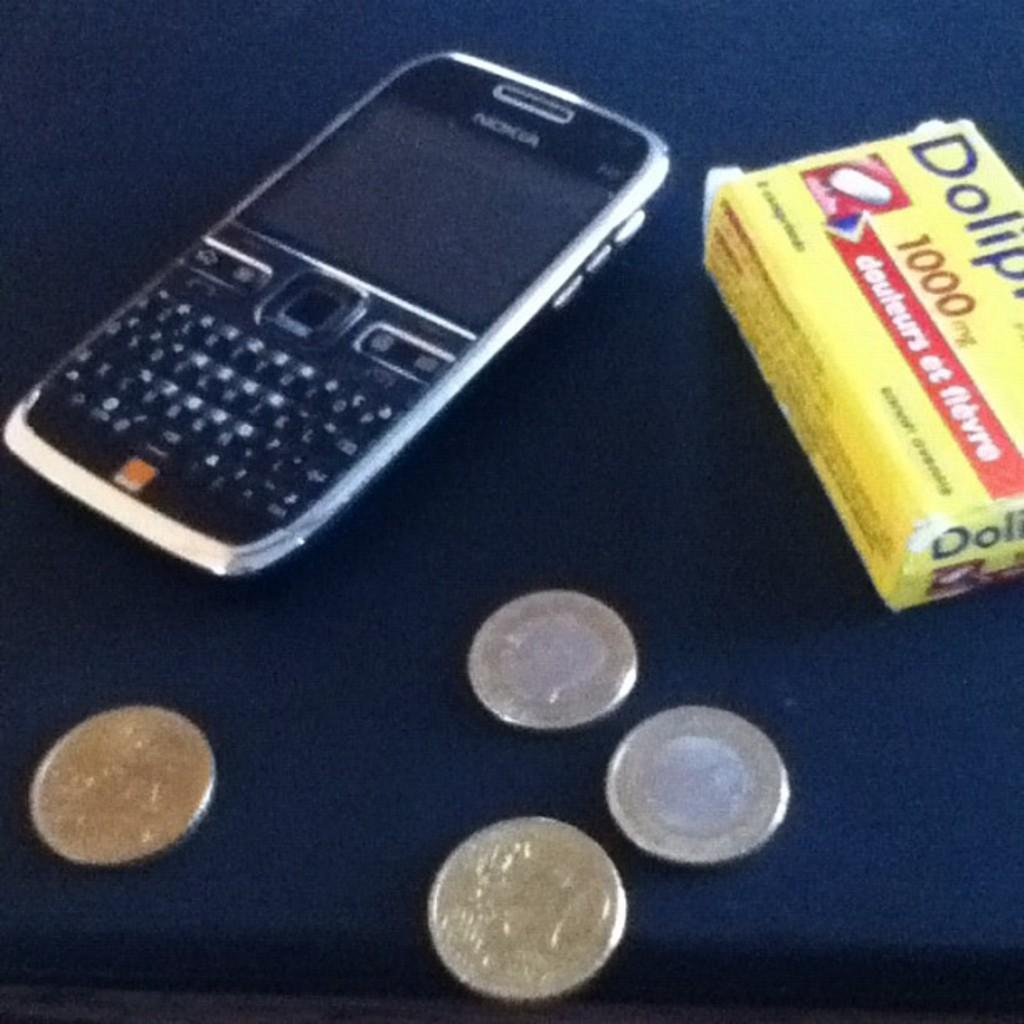Provide a one-sentence caption for the provided image. A cell phone, several coins, and a box of 1000mg pills sit on a table. 